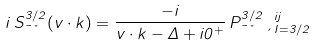Convert formula to latex. <formula><loc_0><loc_0><loc_500><loc_500>i \, S _ { \mu \nu } ^ { 3 / 2 } ( v \cdot k ) = \frac { - i } { v \cdot k - \Delta + i 0 ^ { + } } \, P ^ { 3 / 2 } _ { \mu \nu } \, \xi ^ { i j } _ { I = 3 / 2 }</formula> 